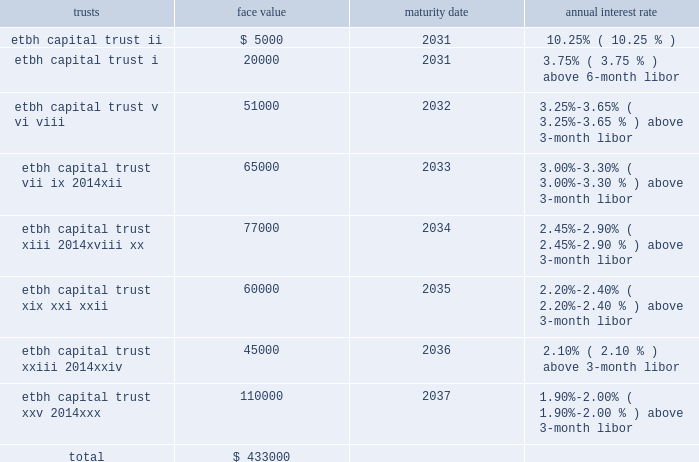Fhlb advances and other borrowings fhlb advances 2014the company had $ 0.7 billion in floating-rate and $ 0.2 billion in fixed-rate fhlb advances at both december 31 , 2013 and 2012 .
The floating-rate advances adjust quarterly based on the libor .
During the year ended december 31 , 2012 , $ 650.0 million of fixed-rate fhlb advances were converted to floating-rate for a total cost of approximately $ 128 million which was capitalized and will be amortized over the remaining maturities using the effective interest method .
In addition , during the year ended december 31 , 2012 , the company paid down in advance of maturity $ 1.0 billion of its fhlb advances and recorded $ 69.1 million in losses on the early extinguishment .
This loss was recorded in the gains ( losses ) on early extinguishment of debt line item in the consolidated statement of income ( loss ) .
The company did not have any similar transactions for the years ended december 31 , 2013 and 2011 .
As a condition of its membership in the fhlb atlanta , the company is required to maintain a fhlb stock investment currently equal to the lesser of : a percentage of 0.12% ( 0.12 % ) of total bank assets ; or a dollar cap amount of $ 20 million .
Additionally , the bank must maintain an activity based stock investment which is currently equal to 4.5% ( 4.5 % ) of the bank 2019s outstanding advances at the time of borrowing .
The company had an investment in fhlb stock of $ 61.4 million and $ 67.4 million at december 31 , 2013 and 2012 , respectively .
The company must also maintain qualified collateral as a percent of its advances , which varies based on the collateral type , and is further adjusted by the outcome of the most recent annual collateral audit and by fhlb 2019s internal ranking of the bank 2019s creditworthiness .
These advances are secured by a pool of mortgage loans and mortgage-backed securities .
At december 31 , 2013 and 2012 , the company pledged loans with a lendable value of $ 3.9 billion and $ 4.8 billion , respectively , of the one- to four-family and home equity loans as collateral in support of both its advances and unused borrowing lines .
Other borrowings 2014prior to 2008 , etbh raised capital through the formation of trusts , which sold trust preferred securities in the capital markets .
The capital securities must be redeemed in whole at the due date , which is generally 30 years after issuance .
Each trust issued floating rate cumulative preferred securities ( 201ctrust preferred securities 201d ) , at par with a liquidation amount of $ 1000 per capital security .
The trusts used the proceeds from the sale of issuances to purchase floating rate junior subordinated debentures ( 201csubordinated debentures 201d ) issued by etbh , which guarantees the trust obligations and contributed proceeds from the sale of its subordinated debentures to e*trade bank in the form of a capital contribution .
The most recent issuance of trust preferred securities occurred in 2007 .
The face values of outstanding trusts at december 31 , 2013 are shown below ( dollars in thousands ) : trusts face value maturity date annual interest rate .

What was the ratio of the company investment in fhlb stock of for 2013 to 2012? 
Rationale: in 2013 the company investment $ 0.91 in fhlb stock for each $ 1 in 2012
Computations: (61.4 / 67.4)
Answer: 0.91098. 